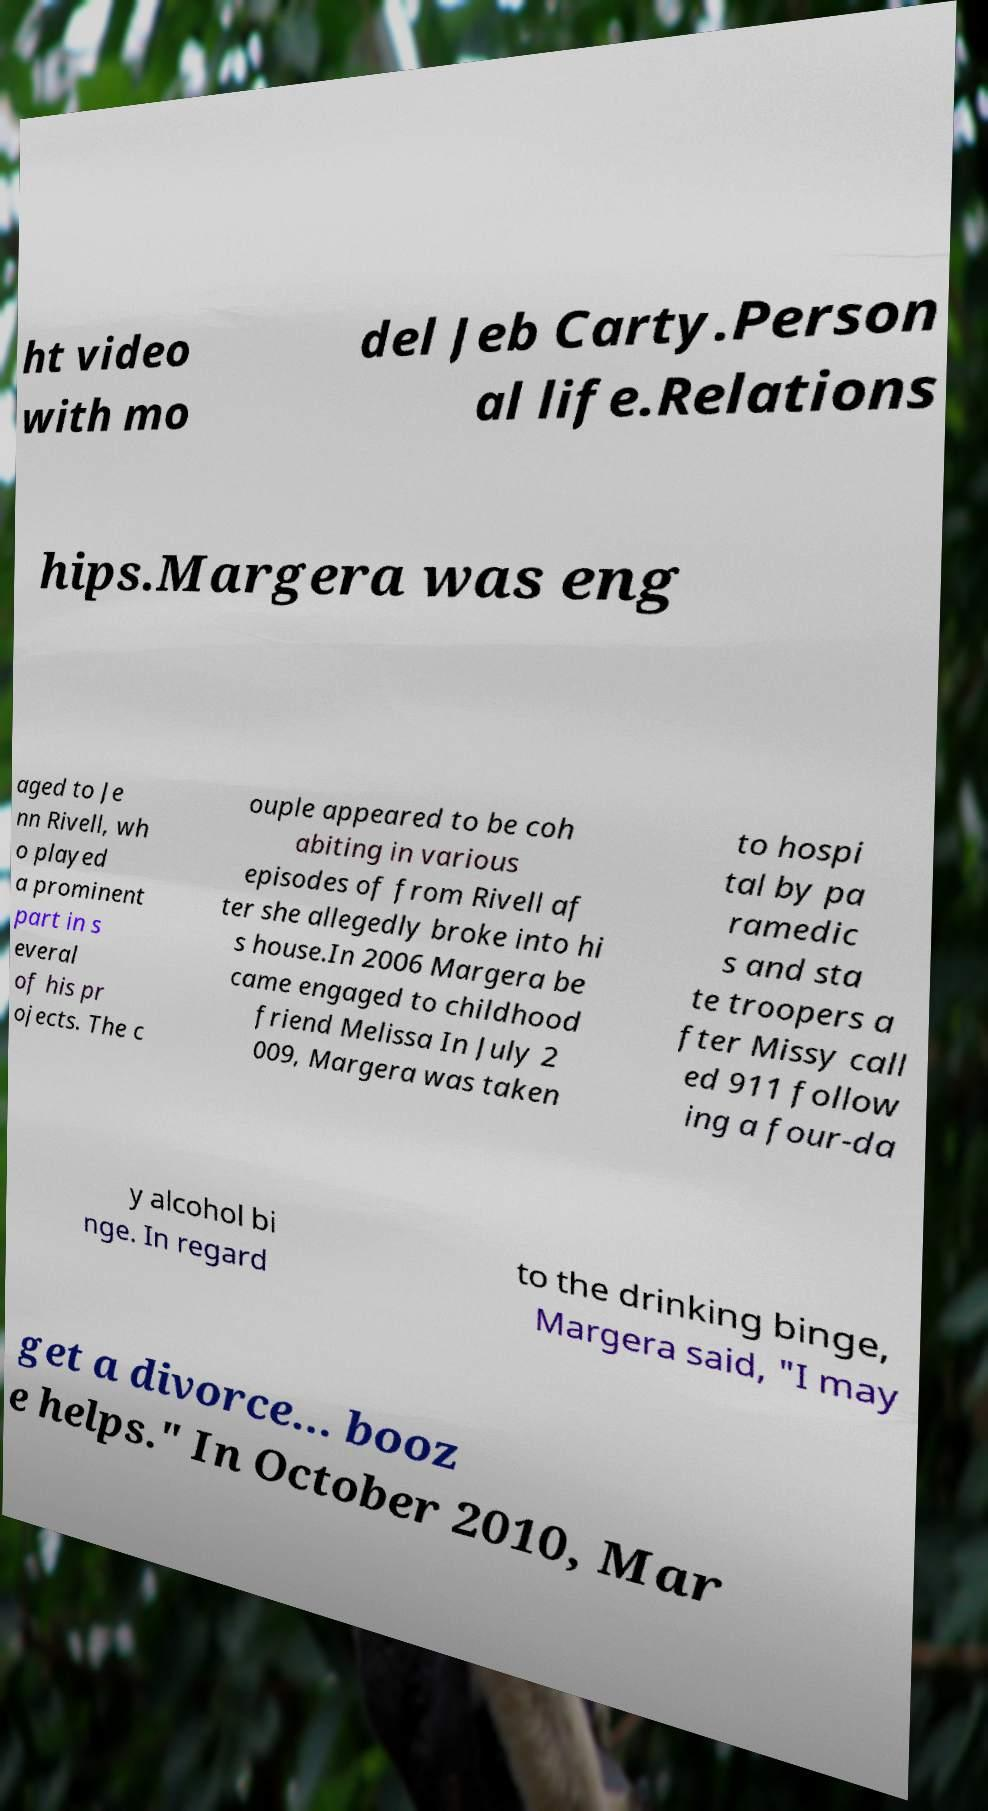Can you read and provide the text displayed in the image?This photo seems to have some interesting text. Can you extract and type it out for me? ht video with mo del Jeb Carty.Person al life.Relations hips.Margera was eng aged to Je nn Rivell, wh o played a prominent part in s everal of his pr ojects. The c ouple appeared to be coh abiting in various episodes of from Rivell af ter she allegedly broke into hi s house.In 2006 Margera be came engaged to childhood friend Melissa In July 2 009, Margera was taken to hospi tal by pa ramedic s and sta te troopers a fter Missy call ed 911 follow ing a four-da y alcohol bi nge. In regard to the drinking binge, Margera said, "I may get a divorce... booz e helps." In October 2010, Mar 